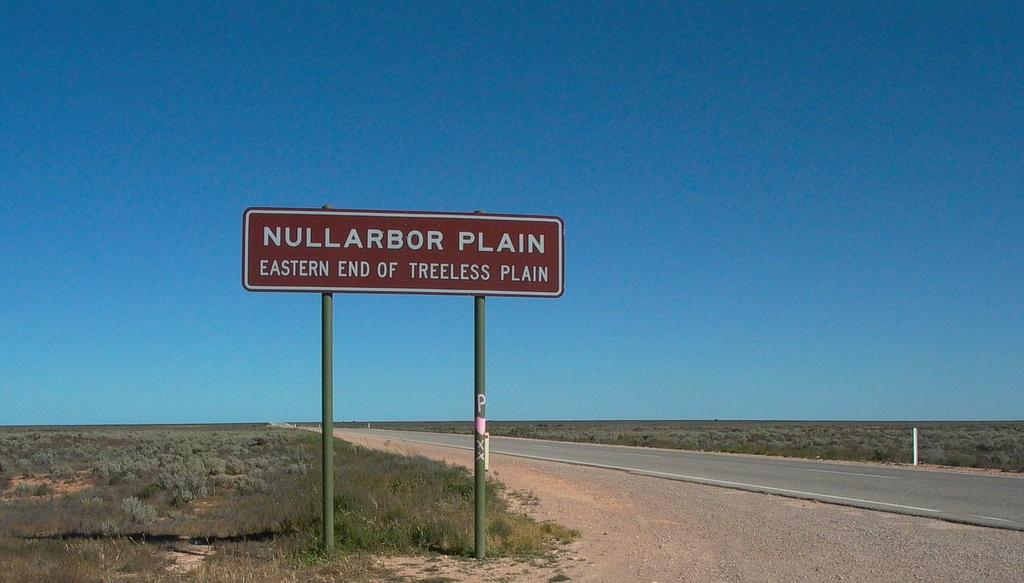<image>
Give a short and clear explanation of the subsequent image. A road with a brown sign reading Eastern end of treeless plain. 